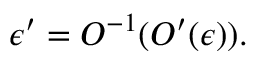Convert formula to latex. <formula><loc_0><loc_0><loc_500><loc_500>\epsilon ^ { \prime } = O ^ { - 1 } ( O ^ { \prime } ( \epsilon ) ) .</formula> 